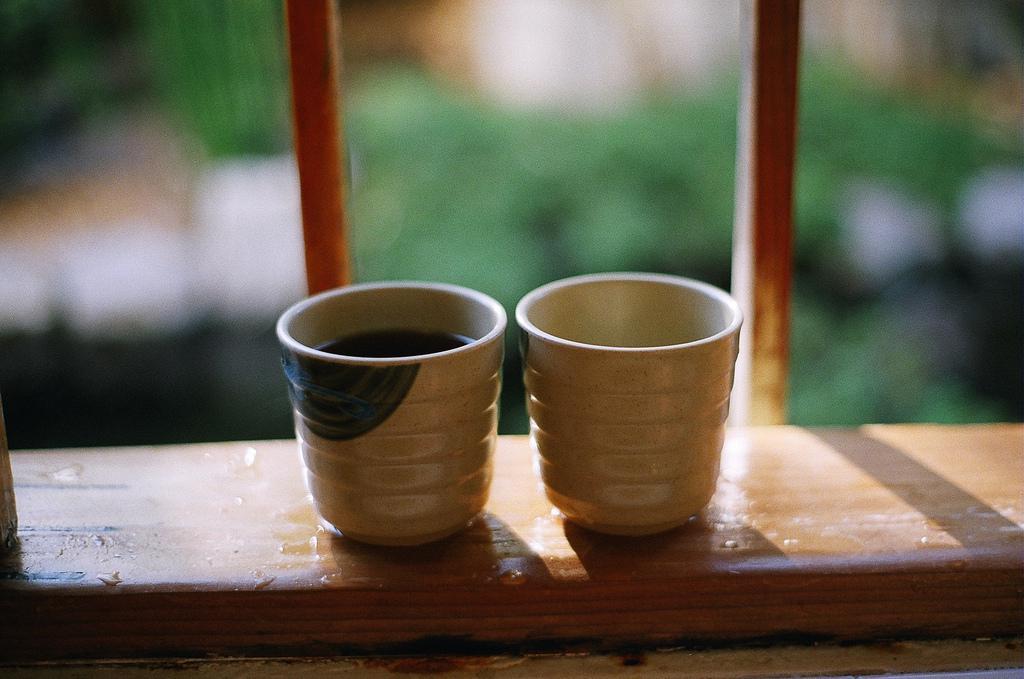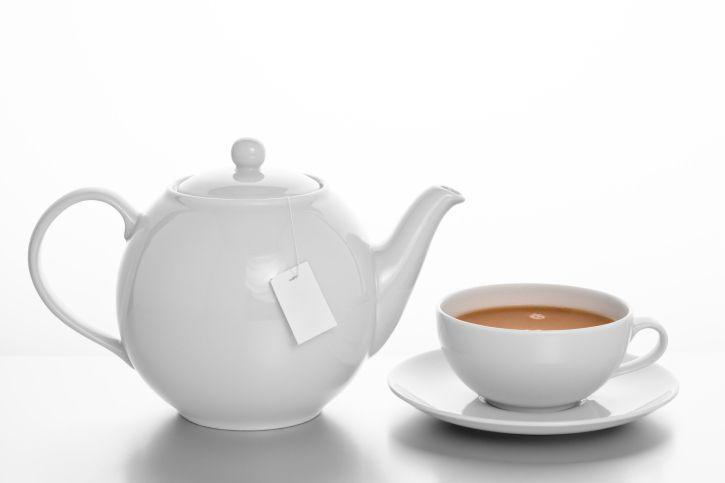The first image is the image on the left, the second image is the image on the right. For the images displayed, is the sentence "The pitcher near the coffee is white." factually correct? Answer yes or no. Yes. The first image is the image on the left, the second image is the image on the right. Assess this claim about the two images: "An image shows a white pitcher next to at least one filled mug on a saucer.". Correct or not? Answer yes or no. Yes. 